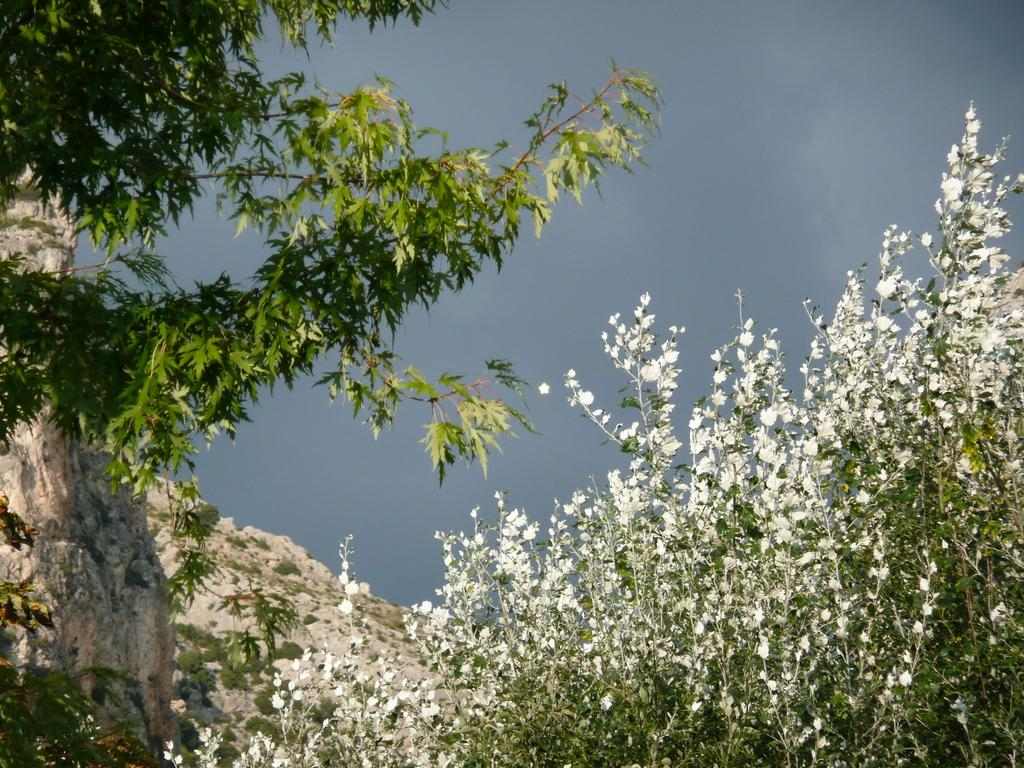What type of vegetation can be seen in the image? There are trees in the image. What part of the natural environment is visible in the image? The sky is visible in the image. What color is the gold notebook in the image? There is no gold notebook present in the image. How many bubbles can be seen floating in the sky in the image? There are no bubbles visible in the image; only trees and the sky are present. 